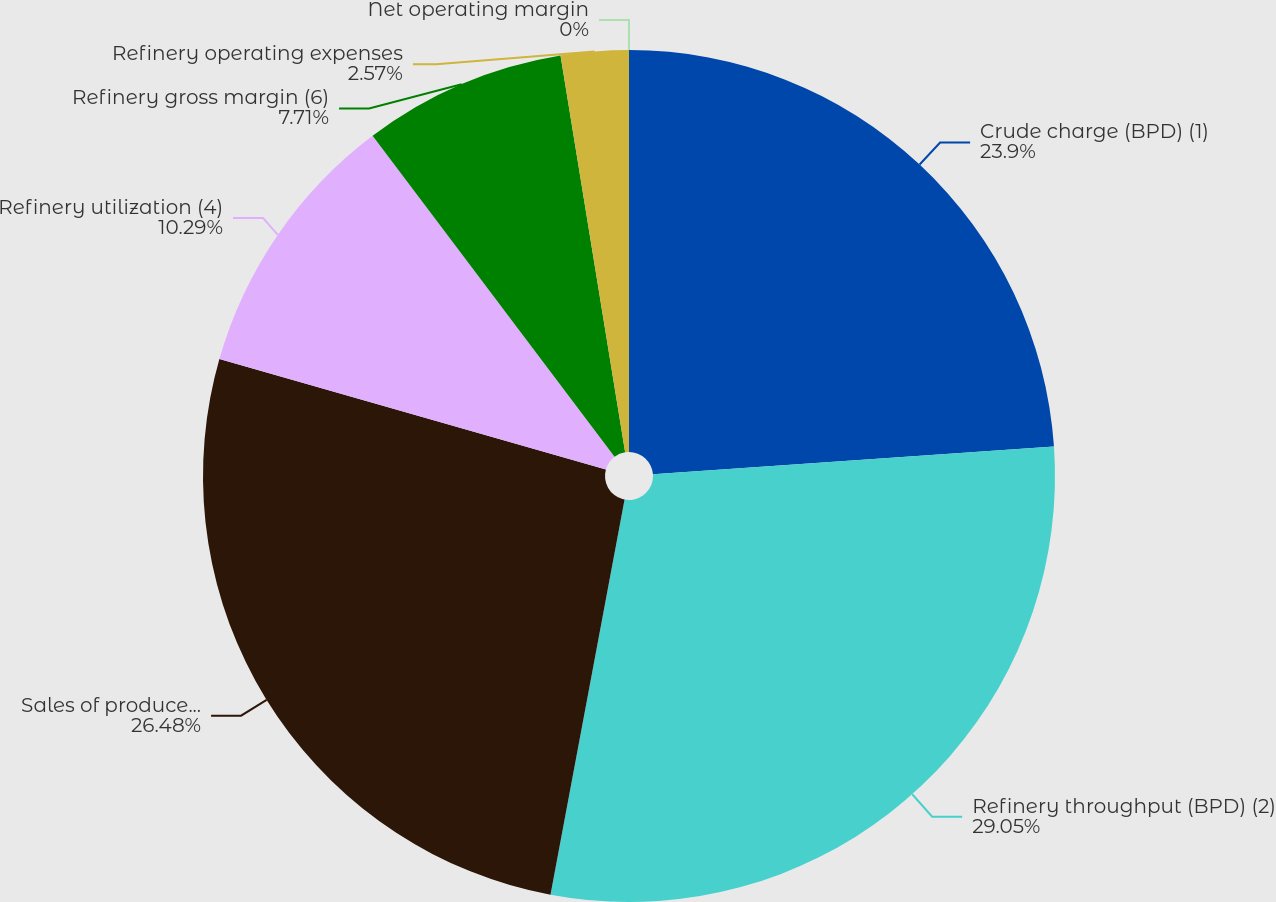<chart> <loc_0><loc_0><loc_500><loc_500><pie_chart><fcel>Crude charge (BPD) (1)<fcel>Refinery throughput (BPD) (2)<fcel>Sales of produced refined<fcel>Refinery utilization (4)<fcel>Refinery gross margin (6)<fcel>Refinery operating expenses<fcel>Net operating margin<nl><fcel>23.9%<fcel>29.05%<fcel>26.48%<fcel>10.29%<fcel>7.71%<fcel>2.57%<fcel>0.0%<nl></chart> 